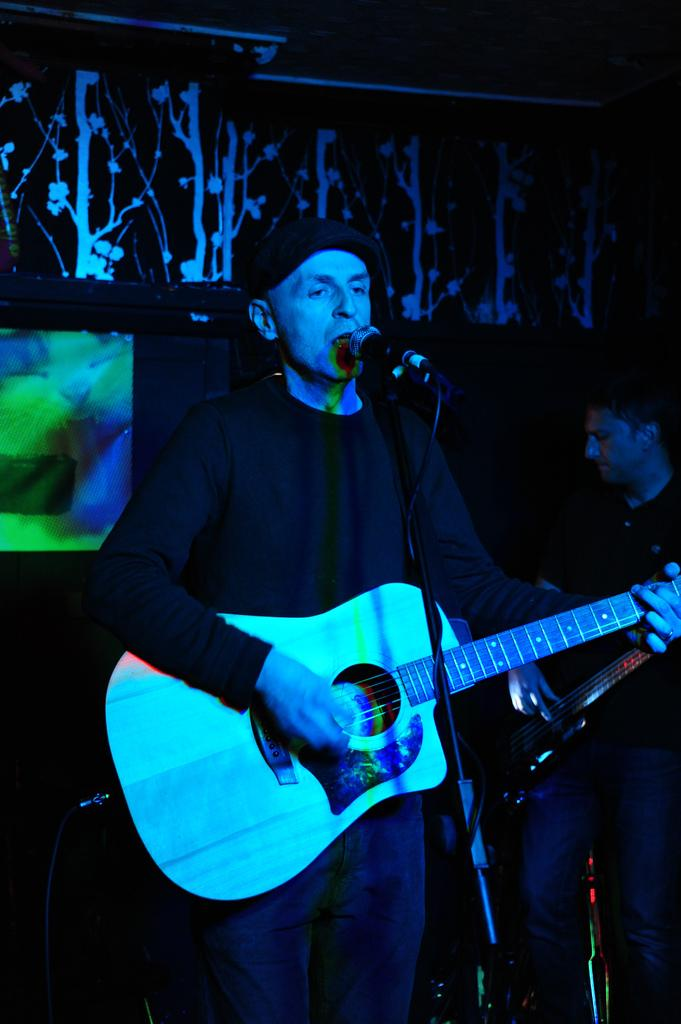What is the man in the image doing? The man is singing in the image. What is the man holding while singing? The man is holding a microphone. What can be observed about the man's clothing? The man is wearing dark color clothes. What type of headwear is the man wearing? The man is wearing a cap. How does the man attract the attention of the stars in the image? There are no stars present in the image, and the man is not trying to attract their attention. 